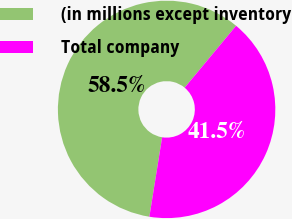Convert chart. <chart><loc_0><loc_0><loc_500><loc_500><pie_chart><fcel>(in millions except inventory<fcel>Total company<nl><fcel>58.5%<fcel>41.5%<nl></chart> 